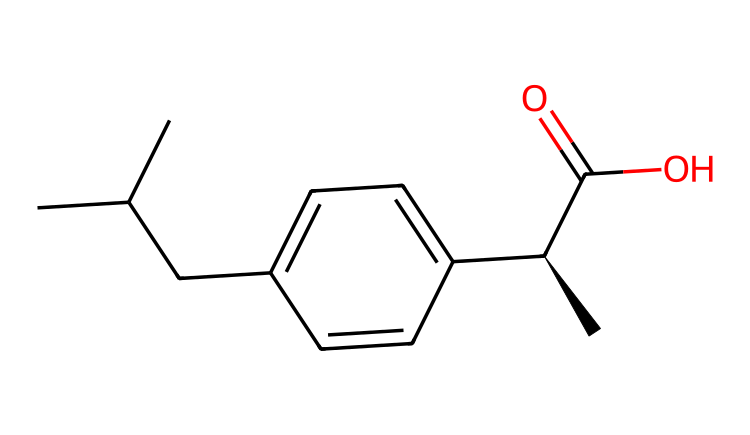What is the molecular formula of ibuprofen? To find the molecular formula, we count the number of each type of atom in the SMILES representation. It contains 13 carbon atoms (C), 18 hydrogen atoms (H), and 2 oxygen atoms (O). Therefore, the molecular formula is C13H18O2.
Answer: C13H18O2 How many chiral centers does ibuprofen have? In the SMILES representation, the notation [C@H] indicates a chiral center. There is only one [C@H] in the structure, meaning that ibuprofen has one chiral center.
Answer: 1 What functional group is present in ibuprofen? The SMILES representation ends with C(=O)O, which represents a carboxylic acid functional group. This type of functional group is characterized by the presence of a carbon atom double-bonded to an oxygen atom and also bonded to a hydroxyl group (-OH).
Answer: carboxylic acid What type of compound is ibuprofen classified as? Since ibuprofen has a chiral center and contains a carboxylic acid functional group, it is classified as a chiral compound (specifically a non-steroidal anti-inflammatory drug, or NSAID).
Answer: chiral compound Is ibuprofen a binary compound? A binary compound consists of two different types of elements. In the case of ibuprofen, we have three elements: carbon, hydrogen, and oxygen. Since it contains more than two types of elements, it is not a binary compound.
Answer: no Which part of the ibuprofen structure contributes to its analgesic properties? In the structure of ibuprofen, the carboxylic acid group (-COOH) is crucial for its analgesic (pain-relieving) properties, as it helps in interacting with specific receptors in the body that modulate pain.
Answer: carboxylic acid 